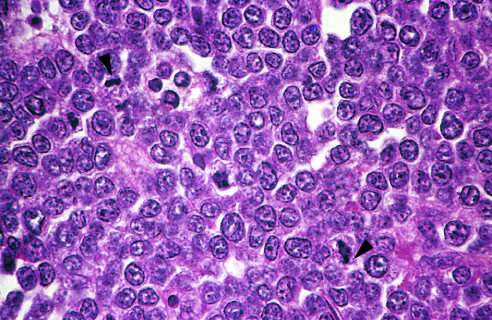how is normal macrophages?
Answer the question using a single word or phrase. Better appreciated at a lower magnification 